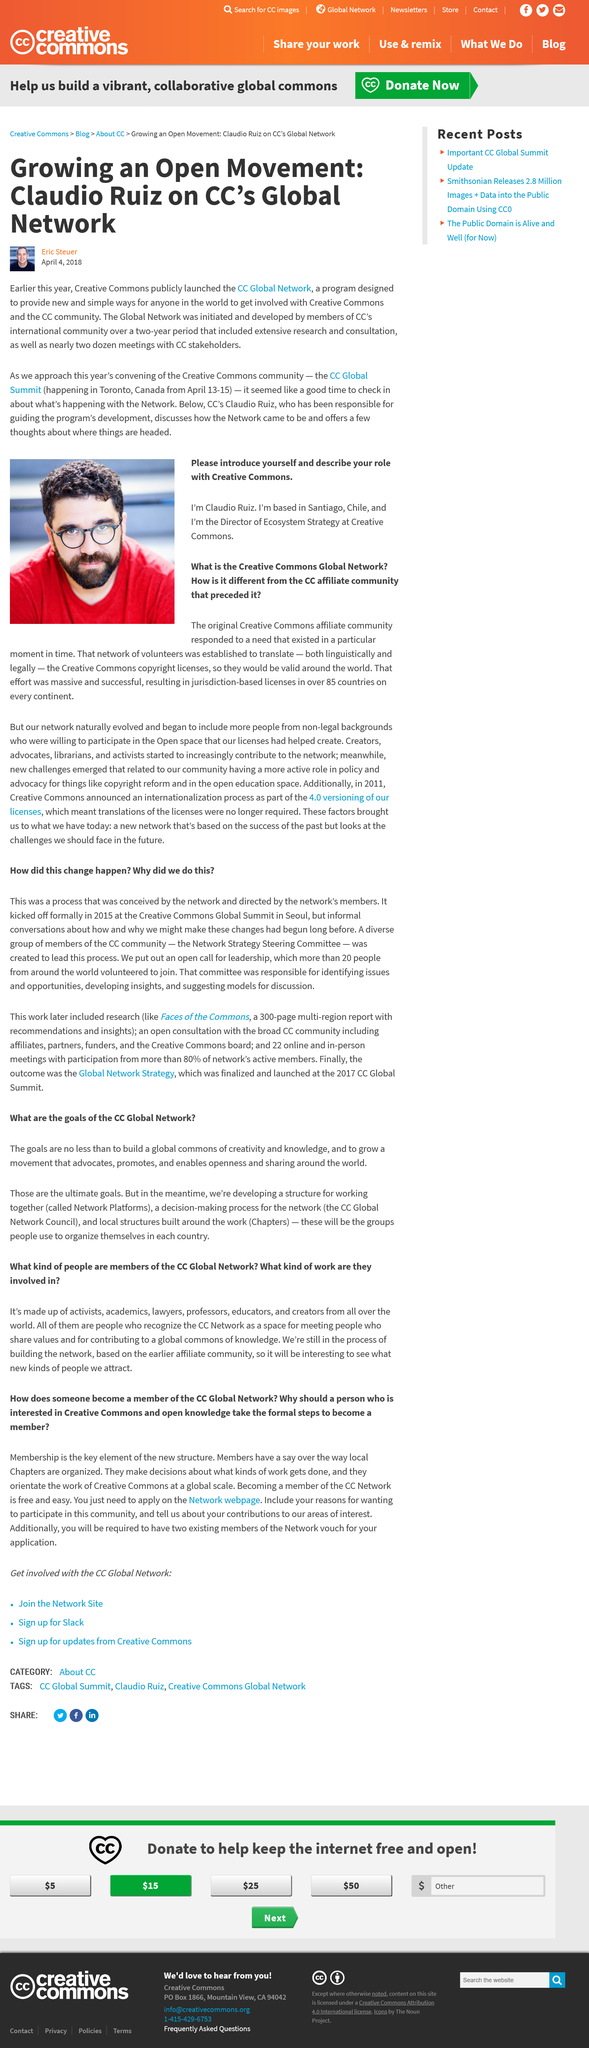Mention a couple of crucial points in this snapshot. Claudio Riuz serves as the Director of Ecosystem Strategy for Creative Commons, a nonprofit organization dedicated to promoting the use and sharing of creative works. The CC Global Summit is scheduled to take place in 2018. CC Global Network people recognize CC Networks as a place to meet individuals who share similar values and contribute to the global commons of knowledge. The Network Strategy Steering Committee includes international leaders from various regions of the world, demonstrating the global reach and importance of the organization. The CC Global Network consists of activists, academics, lawyers, professors, educators, and creators who are dedicated to promoting and protecting intellectual property rights. 